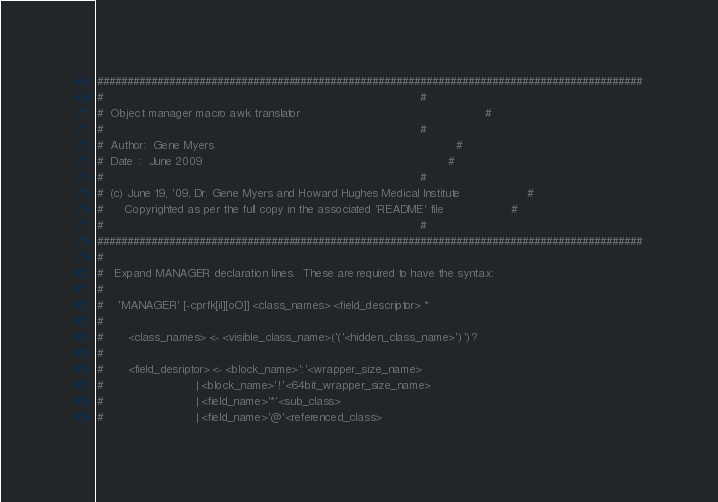Convert code to text. <code><loc_0><loc_0><loc_500><loc_500><_Awk_>###########################################################################################
#                                                                                         #
#  Object manager macro awk translator                                                    #
#                                                                                         #
#  Author:  Gene Myers                                                                    #
#  Date  :  June 2009                                                                     #
#                                                                                         #
#  (c) June 19, '09, Dr. Gene Myers and Howard Hughes Medical Institute                   #
#      Copyrighted as per the full copy in the associated 'README' file                   #
#                                                                                         #
###########################################################################################
#
#   Expand MANAGER declaration lines.  These are required to have the syntax:
#
#    'MANAGER' [-cprfk[iI][oO]] <class_names> <field_descriptor> *
#
#       <class_names> <- <visible_class_name>('('<hidden_class_name>')')?
#
#       <field_desriptor> <- <block_name>':'<wrapper_size_name>
#                          | <block_name>'!'<64bit_wrapper_size_name>
#                          | <field_name>'*'<sub_class>
#                          | <field_name>'@'<referenced_class>
</code> 